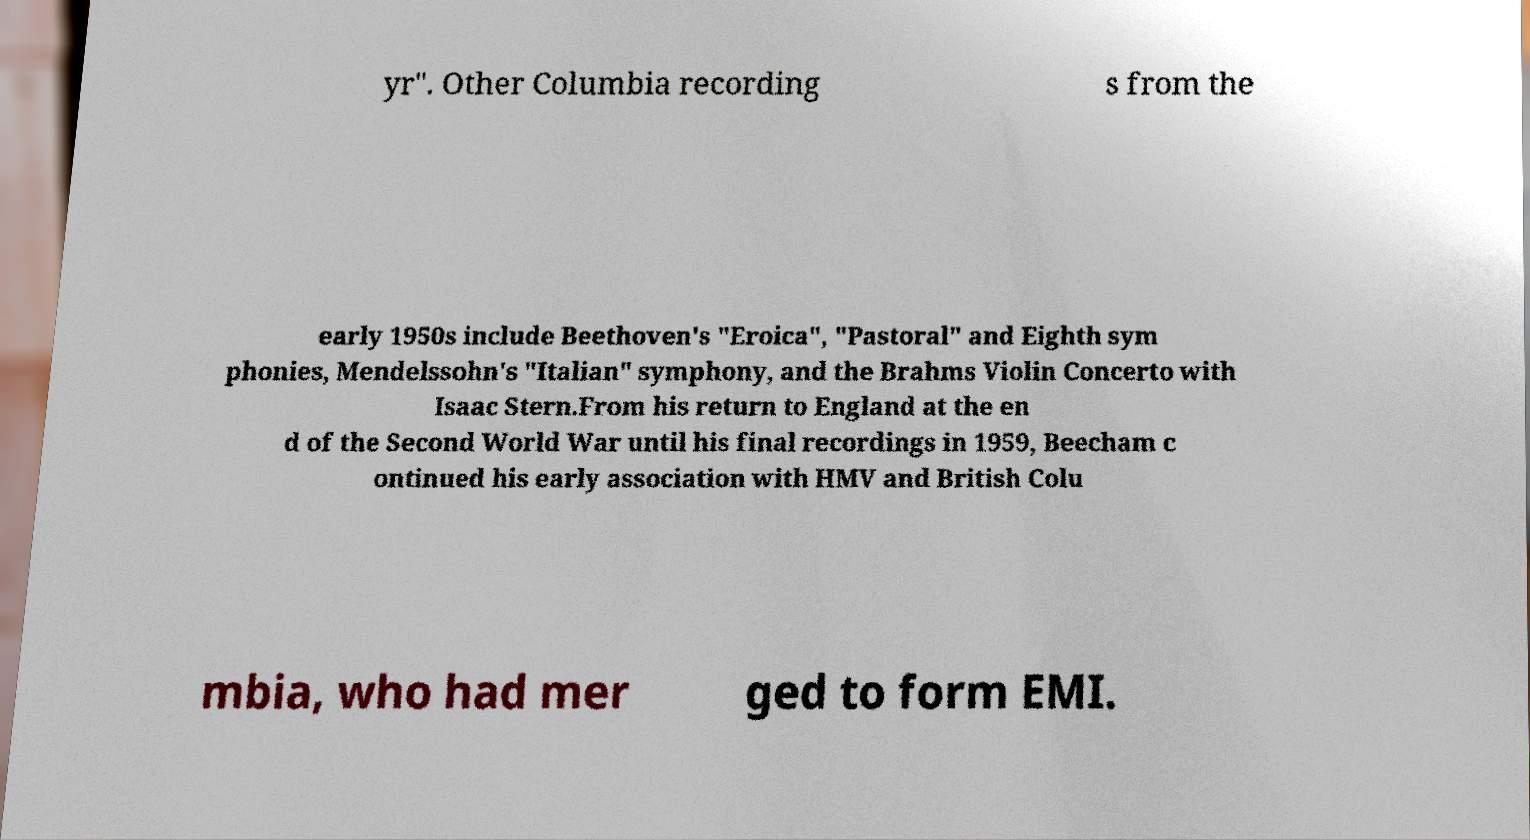There's text embedded in this image that I need extracted. Can you transcribe it verbatim? yr". Other Columbia recording s from the early 1950s include Beethoven's "Eroica", "Pastoral" and Eighth sym phonies, Mendelssohn's "Italian" symphony, and the Brahms Violin Concerto with Isaac Stern.From his return to England at the en d of the Second World War until his final recordings in 1959, Beecham c ontinued his early association with HMV and British Colu mbia, who had mer ged to form EMI. 